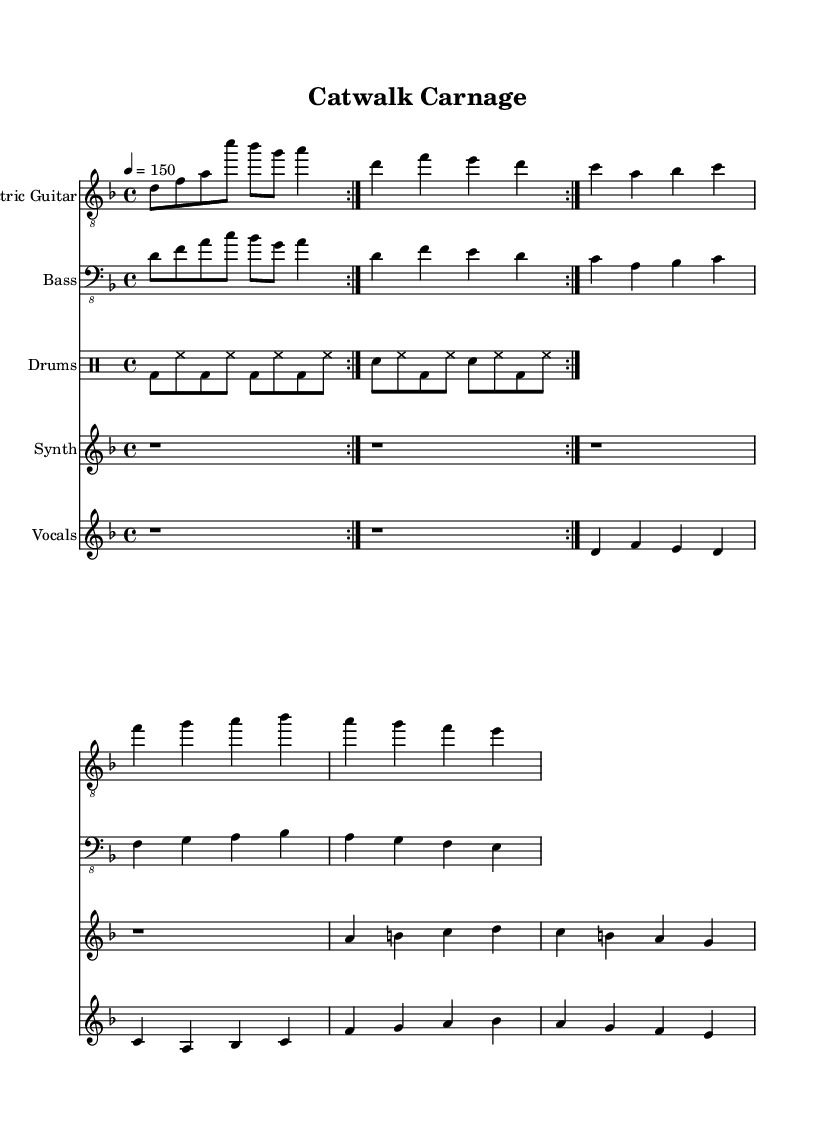What is the key signature of this music? The key signature indicates that the piece is in D minor, which has one flat (B flat). This can be identified by looking at the beginning of the staff where the key signature is located.
Answer: D minor What is the time signature of this music? The time signature is found at the beginning of the score. Here, it is indicated as 4/4, meaning there are four beats in a measure and the quarter note gets one beat.
Answer: 4/4 What is the tempo marking of this music? The tempo marking is given as "4 = 150." This indicates that the quarter note is to be played at a speed of 150 beats per minute, specified near the top of the score.
Answer: 150 How many measures does the electric guitar part repeat? The electric guitar part is indicated to repeat twice, as shown by the "repeat volta 2" notation in the score for that instrument. Therefore, we analyze the guitar section notation for repetition.
Answer: 2 How many different instruments are included in the score? The score specifies the inclusion of five different instruments: Electric Guitar, Bass, Drums, Synthesizer, and Vocals. Counting the individual staff lines confirms this total.
Answer: 5 What is the first note played by the synthesizer? The synthesizer part starts with a rest (notated as 'r'), indicating silence before the first note occurs. The first actual note is A. Therefore, we analyze the first note value after the rest.
Answer: A What genre is specifically represented by the combination of instruments and the darker themes in this piece? The piece embodies the Industrial Metal genre, characterized by heavy guitar riffs, electronic elements, and a thematic exploration of darker aspects, such as the modeling industry's underpinnings, as inferred from the title "Catwalk Carnage." This genre combination solidifies the concept.
Answer: Industrial Metal 